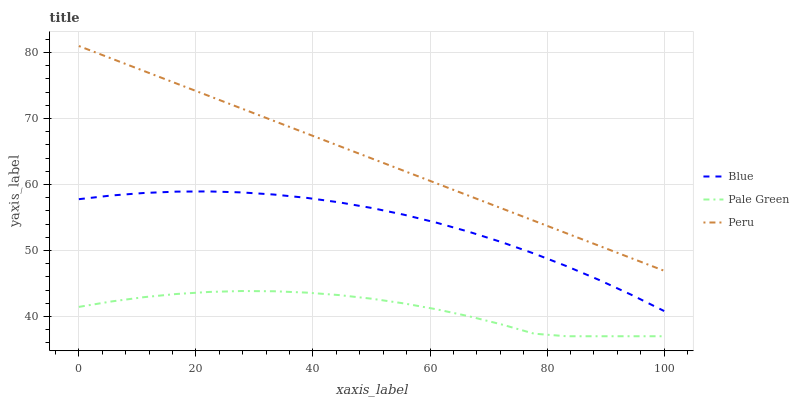Does Pale Green have the minimum area under the curve?
Answer yes or no. Yes. Does Peru have the maximum area under the curve?
Answer yes or no. Yes. Does Peru have the minimum area under the curve?
Answer yes or no. No. Does Pale Green have the maximum area under the curve?
Answer yes or no. No. Is Peru the smoothest?
Answer yes or no. Yes. Is Pale Green the roughest?
Answer yes or no. Yes. Is Pale Green the smoothest?
Answer yes or no. No. Is Peru the roughest?
Answer yes or no. No. Does Pale Green have the lowest value?
Answer yes or no. Yes. Does Peru have the lowest value?
Answer yes or no. No. Does Peru have the highest value?
Answer yes or no. Yes. Does Pale Green have the highest value?
Answer yes or no. No. Is Blue less than Peru?
Answer yes or no. Yes. Is Peru greater than Pale Green?
Answer yes or no. Yes. Does Blue intersect Peru?
Answer yes or no. No. 